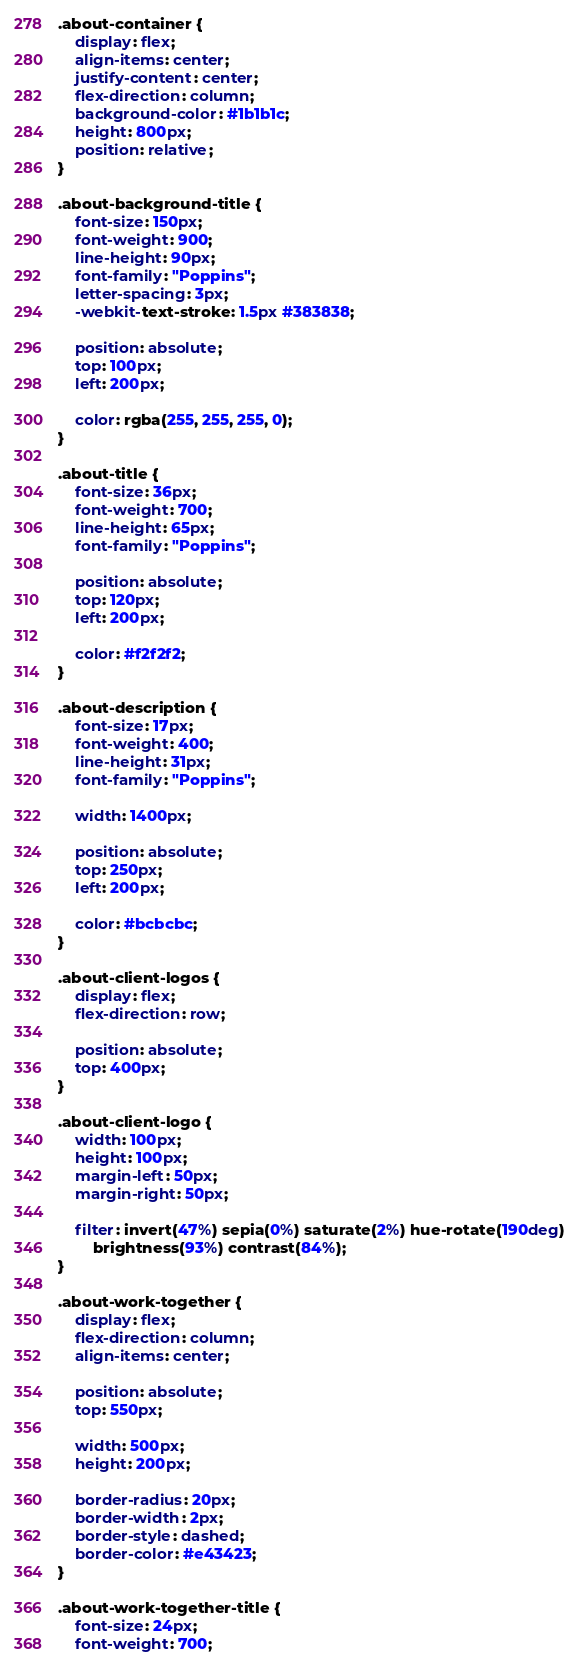Convert code to text. <code><loc_0><loc_0><loc_500><loc_500><_CSS_>.about-container {
	display: flex;
	align-items: center;
	justify-content: center;
	flex-direction: column;
	background-color: #1b1b1c;
	height: 800px;
	position: relative;
}

.about-background-title {
	font-size: 150px;
	font-weight: 900;
	line-height: 90px;
	font-family: "Poppins";
	letter-spacing: 3px;
	-webkit-text-stroke: 1.5px #383838;

	position: absolute;
	top: 100px;
	left: 200px;

	color: rgba(255, 255, 255, 0);
}

.about-title {
	font-size: 36px;
	font-weight: 700;
	line-height: 65px;
	font-family: "Poppins";

	position: absolute;
	top: 120px;
	left: 200px;

	color: #f2f2f2;
}

.about-description {
	font-size: 17px;
	font-weight: 400;
	line-height: 31px;
	font-family: "Poppins";

	width: 1400px;

	position: absolute;
	top: 250px;
	left: 200px;

	color: #bcbcbc;
}

.about-client-logos {
	display: flex;
	flex-direction: row;

	position: absolute;
	top: 400px;
}

.about-client-logo {
	width: 100px;
	height: 100px;
	margin-left: 50px;
	margin-right: 50px;

	filter: invert(47%) sepia(0%) saturate(2%) hue-rotate(190deg)
		brightness(93%) contrast(84%);
}

.about-work-together {
	display: flex;
	flex-direction: column;
	align-items: center;

	position: absolute;
	top: 550px;

	width: 500px;
	height: 200px;

	border-radius: 20px;
	border-width: 2px;
	border-style: dashed;
	border-color: #e43423;
}

.about-work-together-title {
	font-size: 24px;
	font-weight: 700;</code> 